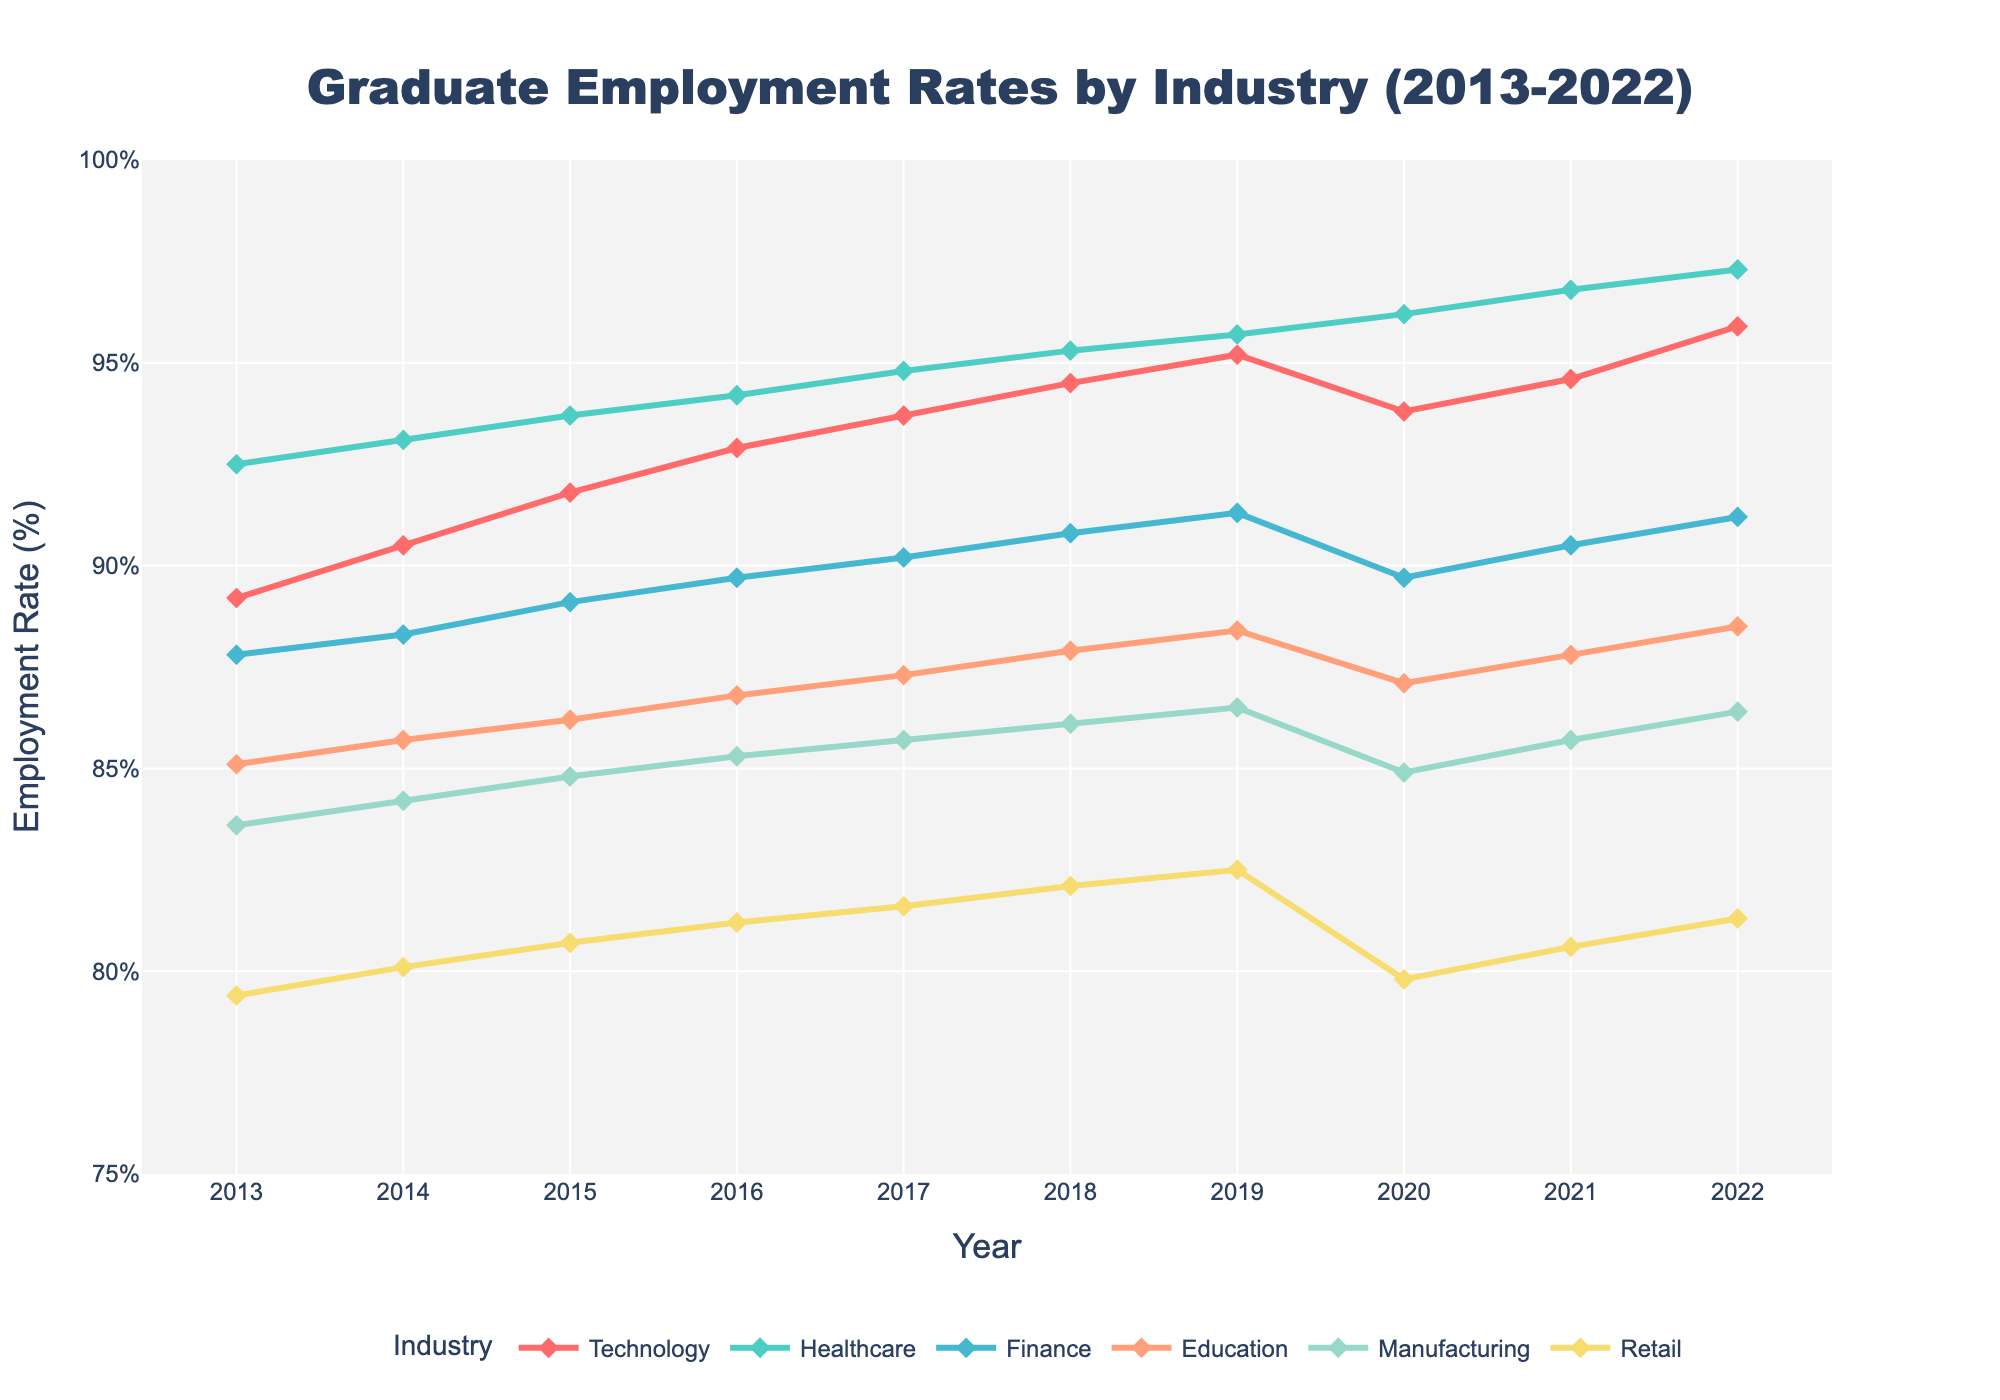What is the highest graduate employment rate in the Technology industry during the past decade? The line for the Technology industry shows the highest point in 2022 at 95.9%.
Answer: 95.9% Which industry had the lowest graduate employment rate in 2013? The Retail industry shows the lowest point in 2013 with an employment rate of 79.4%.
Answer: Retail By how much did the employment rate in Healthcare increase from 2013 to 2022? The Healthcare employment rate in 2013 is 92.5%, and in 2022 it is 97.3%. The increase is 97.3% - 92.5% = 4.8%.
Answer: 4.8% In which year did the Manufacturing industry first exceed an 85% employment rate? The Manufacturing industry line first crosses the 85% mark in 2016.
Answer: 2016 How does the employment rate trend in Finance compare with the trend in Education from 2013 to 2022? Finance trends upwards with minor fluctuations, peaking at 91.3% in 2019 and slightly lower in 2020, then rising again. Education also trends upwards more steadily without drops, reaching 88.5% in 2022. Finance has more variability compared to the steady increase in Education.
Answer: Finance is more variable; Education is steadily increasing Which two industries' employment rates intersect around 2020, and what are their rates? Around 2020, the Technology and Finance lines intersect, both showing a rate close to 89.7%.
Answer: Technology and Finance, 89.7% What is the average graduate employment rate in Retail from 2013 to 2022? Summing up Retail rates: 79.4 + 80.1 + 80.7 + 81.2 + 81.6 + 82.1 + 82.5 + 79.8 + 80.6 + 81.3 = 808.3. There are 10 years; therefore, the average is 808.3 / 10 = 80.83%.
Answer: 80.83% Did the Healthcare industry consistently remain above the 90% employment rate throughout the past decade? The line for the Healthcare industry stays consistently above the 90% mark from 2013 to 2022.
Answer: Yes Compare the trends in the Technology and Manufacturing industries over the past decade. Which had a more significant increase in employment rate? Technology increased from 89.2% in 2013 to 95.9% in 2022, an increase of 6.7%. Manufacturing went from 83.6% in 2013 to 86.4% in 2022, a 2.8% increase. Technology had a more significant increase.
Answer: Technology had a more significant increase 